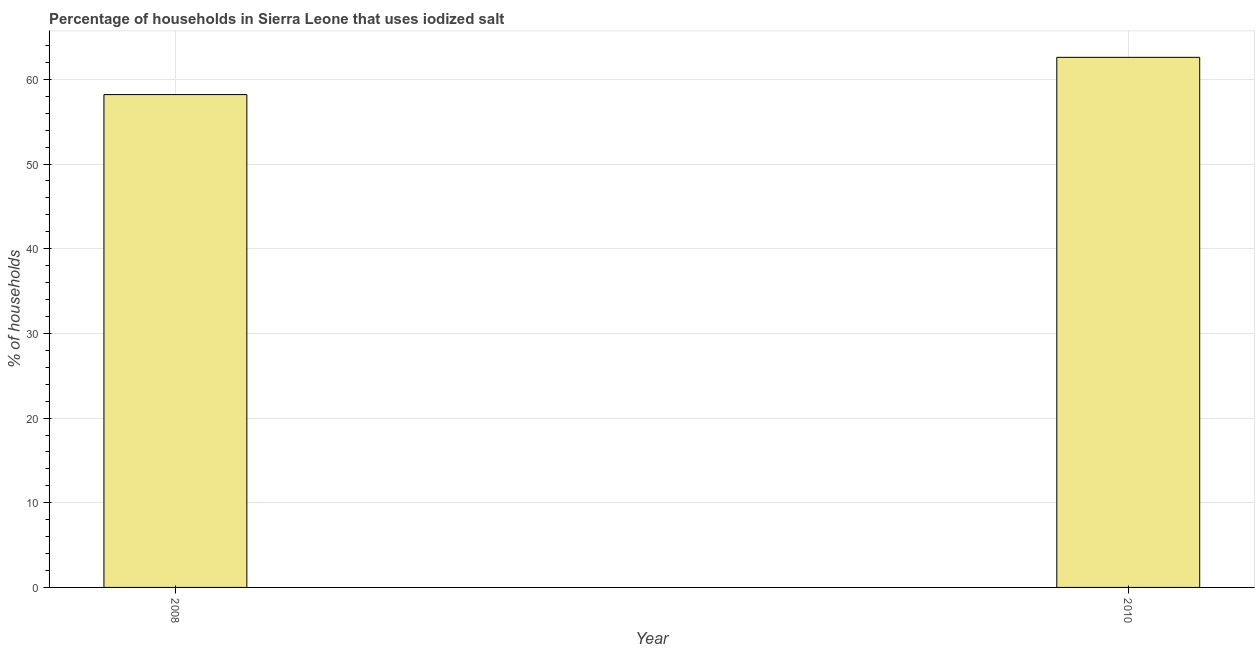What is the title of the graph?
Your answer should be compact. Percentage of households in Sierra Leone that uses iodized salt. What is the label or title of the X-axis?
Provide a short and direct response. Year. What is the label or title of the Y-axis?
Provide a short and direct response. % of households. What is the percentage of households where iodized salt is consumed in 2010?
Your response must be concise. 62.6. Across all years, what is the maximum percentage of households where iodized salt is consumed?
Keep it short and to the point. 62.6. Across all years, what is the minimum percentage of households where iodized salt is consumed?
Provide a short and direct response. 58.2. In which year was the percentage of households where iodized salt is consumed minimum?
Your answer should be very brief. 2008. What is the sum of the percentage of households where iodized salt is consumed?
Your answer should be compact. 120.8. What is the average percentage of households where iodized salt is consumed per year?
Make the answer very short. 60.4. What is the median percentage of households where iodized salt is consumed?
Your answer should be compact. 60.4. Do a majority of the years between 2008 and 2010 (inclusive) have percentage of households where iodized salt is consumed greater than 32 %?
Your answer should be very brief. Yes. What is the ratio of the percentage of households where iodized salt is consumed in 2008 to that in 2010?
Your answer should be very brief. 0.93. Is the percentage of households where iodized salt is consumed in 2008 less than that in 2010?
Your response must be concise. Yes. How many bars are there?
Offer a very short reply. 2. Are all the bars in the graph horizontal?
Keep it short and to the point. No. What is the difference between two consecutive major ticks on the Y-axis?
Make the answer very short. 10. What is the % of households in 2008?
Ensure brevity in your answer.  58.2. What is the % of households in 2010?
Make the answer very short. 62.6. What is the difference between the % of households in 2008 and 2010?
Your response must be concise. -4.4. 